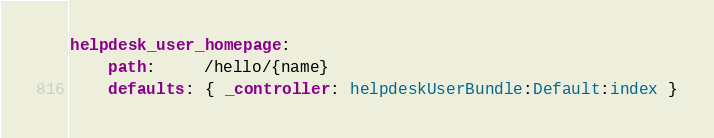Convert code to text. <code><loc_0><loc_0><loc_500><loc_500><_YAML_>helpdesk_user_homepage:
    path:     /hello/{name}
    defaults: { _controller: helpdeskUserBundle:Default:index }
</code> 